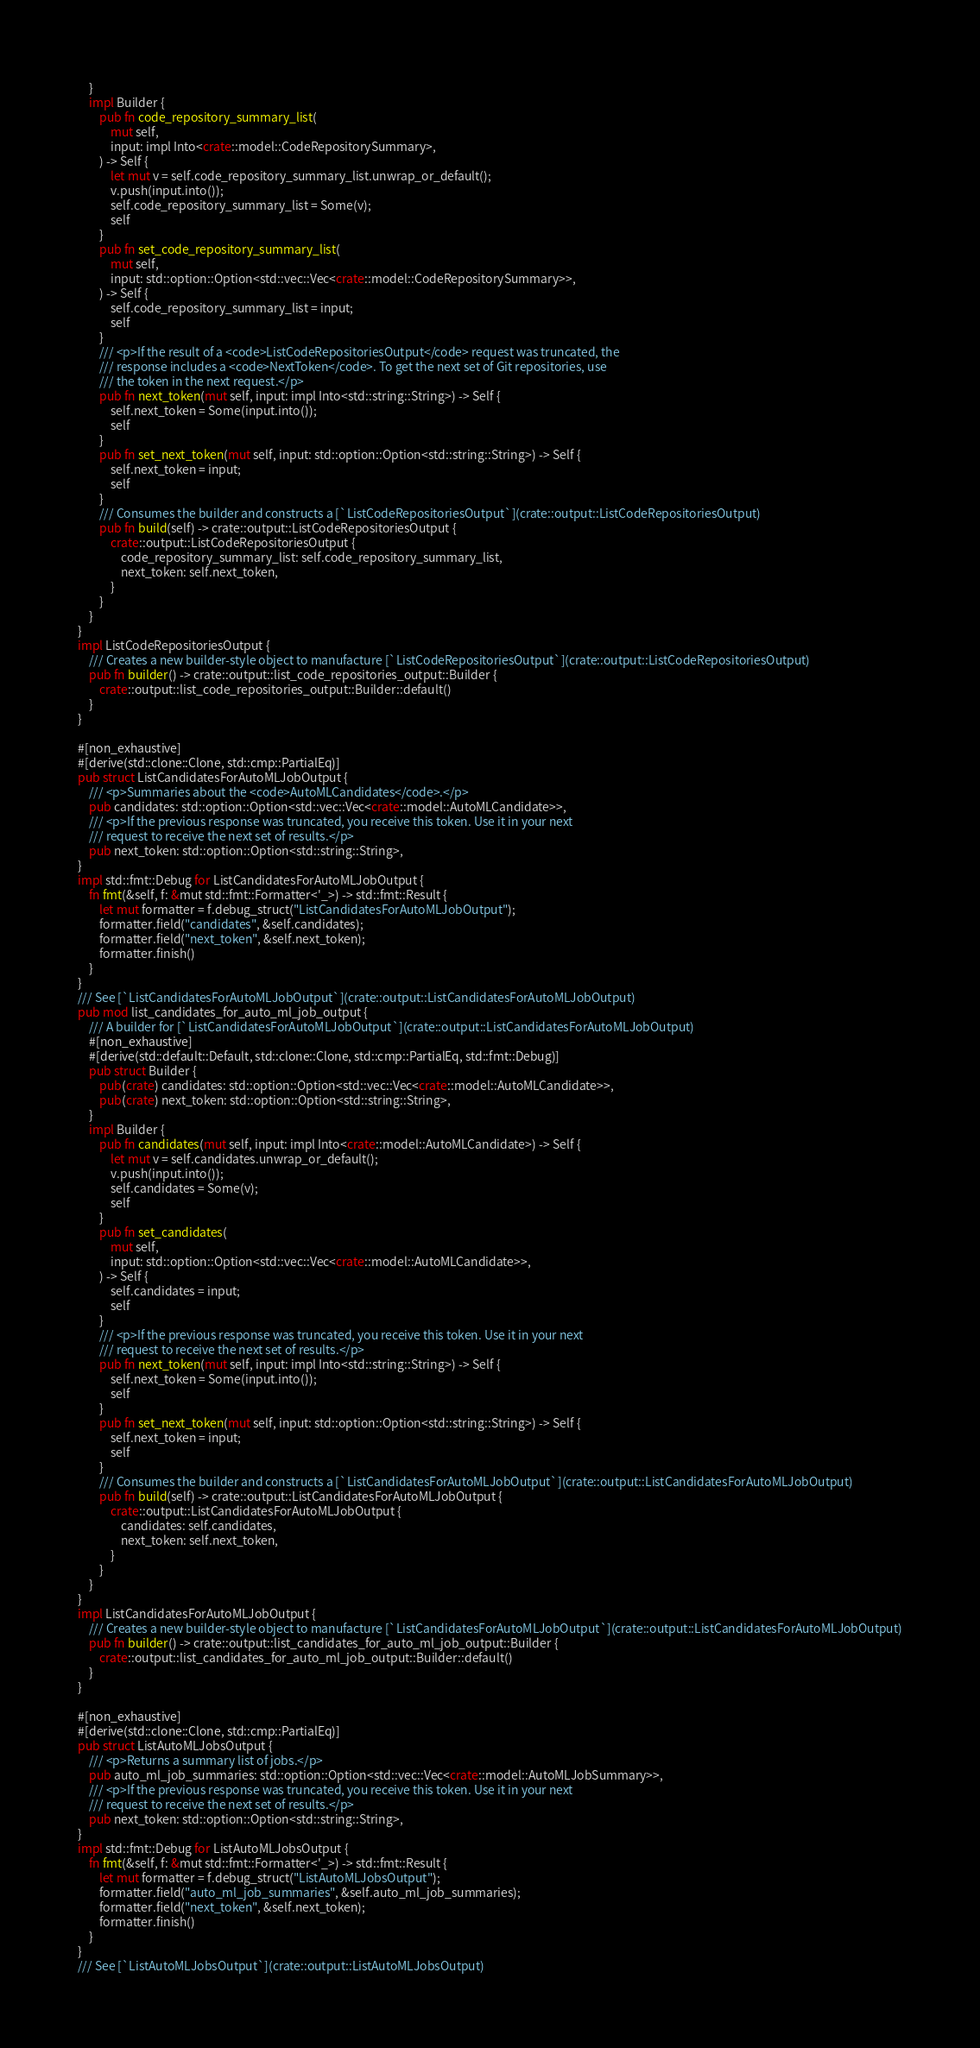<code> <loc_0><loc_0><loc_500><loc_500><_Rust_>    }
    impl Builder {
        pub fn code_repository_summary_list(
            mut self,
            input: impl Into<crate::model::CodeRepositorySummary>,
        ) -> Self {
            let mut v = self.code_repository_summary_list.unwrap_or_default();
            v.push(input.into());
            self.code_repository_summary_list = Some(v);
            self
        }
        pub fn set_code_repository_summary_list(
            mut self,
            input: std::option::Option<std::vec::Vec<crate::model::CodeRepositorySummary>>,
        ) -> Self {
            self.code_repository_summary_list = input;
            self
        }
        /// <p>If the result of a <code>ListCodeRepositoriesOutput</code> request was truncated, the
        /// response includes a <code>NextToken</code>. To get the next set of Git repositories, use
        /// the token in the next request.</p>
        pub fn next_token(mut self, input: impl Into<std::string::String>) -> Self {
            self.next_token = Some(input.into());
            self
        }
        pub fn set_next_token(mut self, input: std::option::Option<std::string::String>) -> Self {
            self.next_token = input;
            self
        }
        /// Consumes the builder and constructs a [`ListCodeRepositoriesOutput`](crate::output::ListCodeRepositoriesOutput)
        pub fn build(self) -> crate::output::ListCodeRepositoriesOutput {
            crate::output::ListCodeRepositoriesOutput {
                code_repository_summary_list: self.code_repository_summary_list,
                next_token: self.next_token,
            }
        }
    }
}
impl ListCodeRepositoriesOutput {
    /// Creates a new builder-style object to manufacture [`ListCodeRepositoriesOutput`](crate::output::ListCodeRepositoriesOutput)
    pub fn builder() -> crate::output::list_code_repositories_output::Builder {
        crate::output::list_code_repositories_output::Builder::default()
    }
}

#[non_exhaustive]
#[derive(std::clone::Clone, std::cmp::PartialEq)]
pub struct ListCandidatesForAutoMLJobOutput {
    /// <p>Summaries about the <code>AutoMLCandidates</code>.</p>
    pub candidates: std::option::Option<std::vec::Vec<crate::model::AutoMLCandidate>>,
    /// <p>If the previous response was truncated, you receive this token. Use it in your next
    /// request to receive the next set of results.</p>
    pub next_token: std::option::Option<std::string::String>,
}
impl std::fmt::Debug for ListCandidatesForAutoMLJobOutput {
    fn fmt(&self, f: &mut std::fmt::Formatter<'_>) -> std::fmt::Result {
        let mut formatter = f.debug_struct("ListCandidatesForAutoMLJobOutput");
        formatter.field("candidates", &self.candidates);
        formatter.field("next_token", &self.next_token);
        formatter.finish()
    }
}
/// See [`ListCandidatesForAutoMLJobOutput`](crate::output::ListCandidatesForAutoMLJobOutput)
pub mod list_candidates_for_auto_ml_job_output {
    /// A builder for [`ListCandidatesForAutoMLJobOutput`](crate::output::ListCandidatesForAutoMLJobOutput)
    #[non_exhaustive]
    #[derive(std::default::Default, std::clone::Clone, std::cmp::PartialEq, std::fmt::Debug)]
    pub struct Builder {
        pub(crate) candidates: std::option::Option<std::vec::Vec<crate::model::AutoMLCandidate>>,
        pub(crate) next_token: std::option::Option<std::string::String>,
    }
    impl Builder {
        pub fn candidates(mut self, input: impl Into<crate::model::AutoMLCandidate>) -> Self {
            let mut v = self.candidates.unwrap_or_default();
            v.push(input.into());
            self.candidates = Some(v);
            self
        }
        pub fn set_candidates(
            mut self,
            input: std::option::Option<std::vec::Vec<crate::model::AutoMLCandidate>>,
        ) -> Self {
            self.candidates = input;
            self
        }
        /// <p>If the previous response was truncated, you receive this token. Use it in your next
        /// request to receive the next set of results.</p>
        pub fn next_token(mut self, input: impl Into<std::string::String>) -> Self {
            self.next_token = Some(input.into());
            self
        }
        pub fn set_next_token(mut self, input: std::option::Option<std::string::String>) -> Self {
            self.next_token = input;
            self
        }
        /// Consumes the builder and constructs a [`ListCandidatesForAutoMLJobOutput`](crate::output::ListCandidatesForAutoMLJobOutput)
        pub fn build(self) -> crate::output::ListCandidatesForAutoMLJobOutput {
            crate::output::ListCandidatesForAutoMLJobOutput {
                candidates: self.candidates,
                next_token: self.next_token,
            }
        }
    }
}
impl ListCandidatesForAutoMLJobOutput {
    /// Creates a new builder-style object to manufacture [`ListCandidatesForAutoMLJobOutput`](crate::output::ListCandidatesForAutoMLJobOutput)
    pub fn builder() -> crate::output::list_candidates_for_auto_ml_job_output::Builder {
        crate::output::list_candidates_for_auto_ml_job_output::Builder::default()
    }
}

#[non_exhaustive]
#[derive(std::clone::Clone, std::cmp::PartialEq)]
pub struct ListAutoMLJobsOutput {
    /// <p>Returns a summary list of jobs.</p>
    pub auto_ml_job_summaries: std::option::Option<std::vec::Vec<crate::model::AutoMLJobSummary>>,
    /// <p>If the previous response was truncated, you receive this token. Use it in your next
    /// request to receive the next set of results.</p>
    pub next_token: std::option::Option<std::string::String>,
}
impl std::fmt::Debug for ListAutoMLJobsOutput {
    fn fmt(&self, f: &mut std::fmt::Formatter<'_>) -> std::fmt::Result {
        let mut formatter = f.debug_struct("ListAutoMLJobsOutput");
        formatter.field("auto_ml_job_summaries", &self.auto_ml_job_summaries);
        formatter.field("next_token", &self.next_token);
        formatter.finish()
    }
}
/// See [`ListAutoMLJobsOutput`](crate::output::ListAutoMLJobsOutput)</code> 